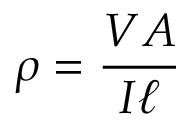Convert formula to latex. <formula><loc_0><loc_0><loc_500><loc_500>\rho = { \frac { V A } { I \ell } }</formula> 